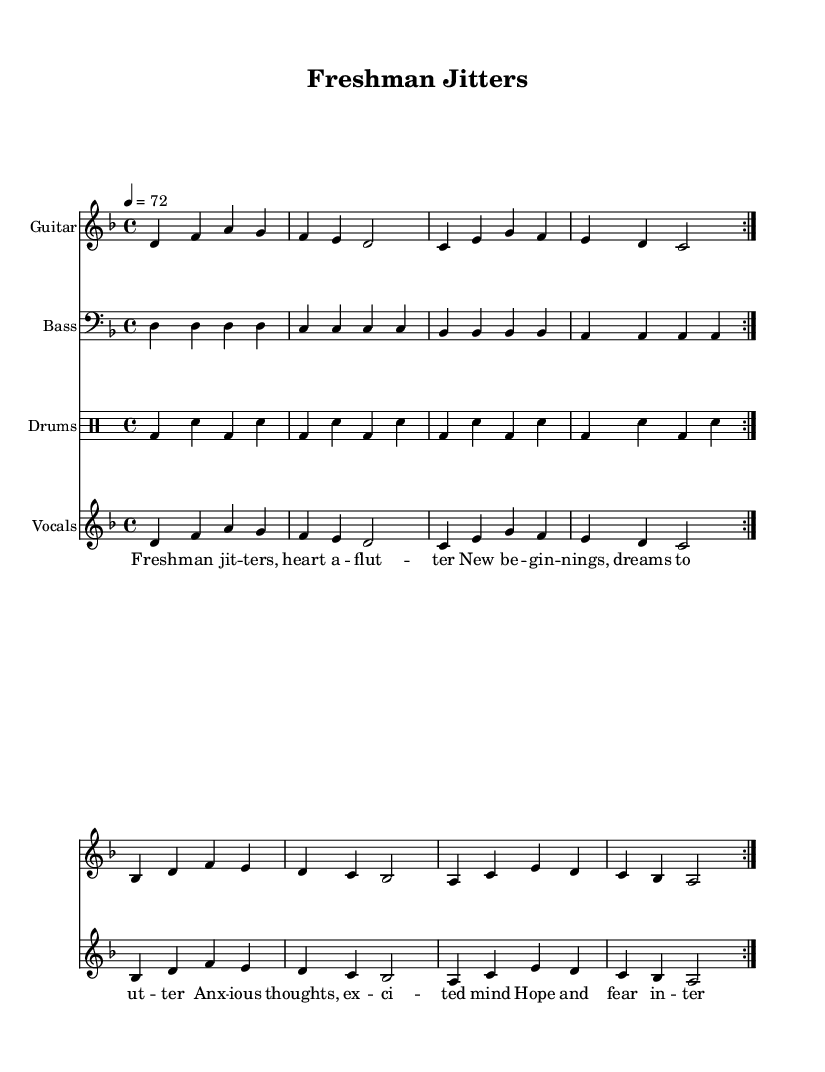What is the key signature of this music? The key signature indicates D minor, which has one flat (B flat). This can be identified by looking at the beginning of the staff where the sharps and flats are placed.
Answer: D minor What is the time signature of this piece? The time signature is 4/4, which can be seen at the beginning of the music notation. It indicates that there are four beats in a measure and each quarter note receives one beat.
Answer: 4/4 What is the tempo marking for this piece? The tempo marking is 72 beats per minute, indicated at the beginning of the score. This informs the performer of the speed at which the piece should be played.
Answer: 72 How many times are the sections repeated? The sections are repeated twice, as indicated by the "repeat volta 2" markings in the score. This means that the performer should play the segment two times.
Answer: twice What is the main theme expressed in the lyrics? The lyrics discuss themes of anxiety and excitement about starting university life, emphasizing feelings like "Freshman jitters" and "Hope and fear intertwined." This can be deduced from the content of the lyrics written under the melody.
Answer: Anxiety and excitement What instrument plays the melody? The vocals carry the melody in this piece, as can be seen in the staff labeled "Vocals" where the melody notes appear. Vocals generally deliver the lyrics and melody together in most songs, especially in punk ballads.
Answer: Vocals What type of drums are used in this piece? The drum pattern indicates both bass and snare drums are used, evidenced by the notation in the "Drums" staff where the drum sounds are represented. This specific usage is typical in punk music for creating drive and energy.
Answer: Bass and snare 